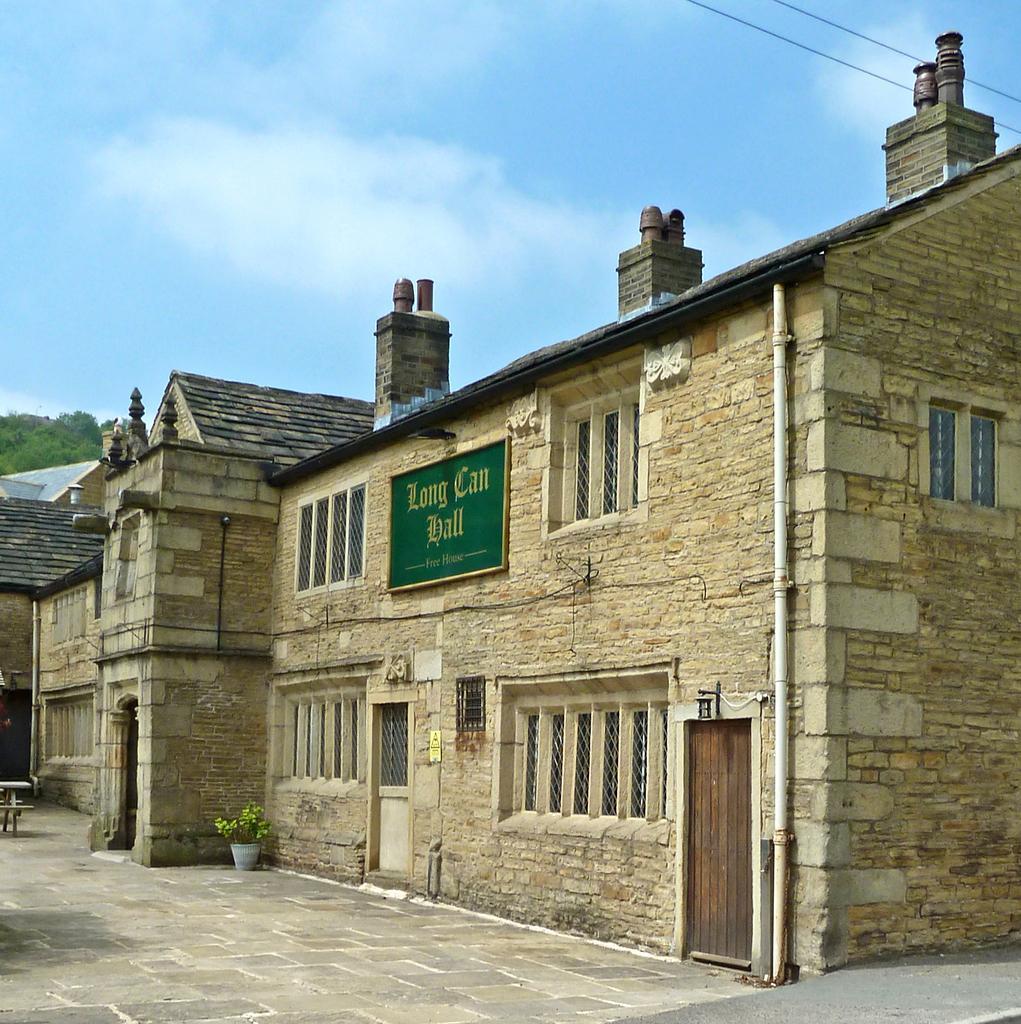Describe this image in one or two sentences. In this image we can see a building with windows and door. On the building there is a board with something written. Near to the building there is a pot with a plant. In the background there is sky with clouds. On the left side we can see trees. On the wall of the building there is a pipe. 